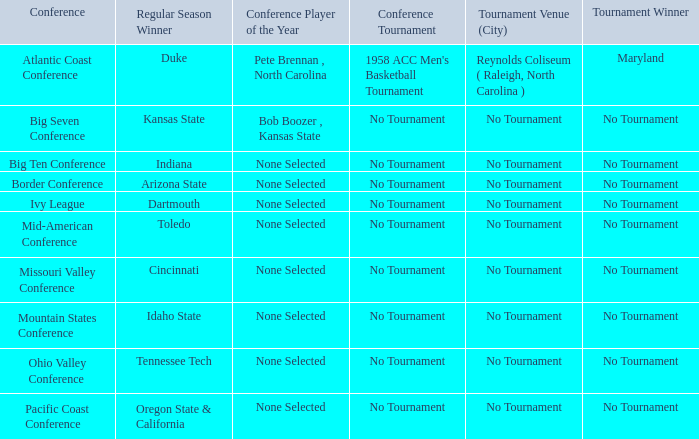Who won the regular season when Maryland won the tournament? Duke. 